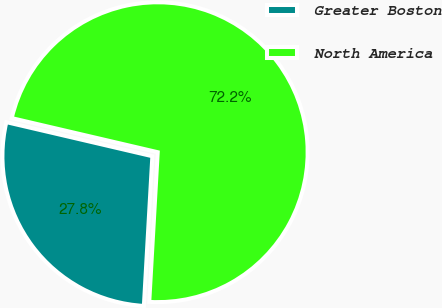Convert chart. <chart><loc_0><loc_0><loc_500><loc_500><pie_chart><fcel>Greater Boston<fcel>North America<nl><fcel>27.75%<fcel>72.25%<nl></chart> 